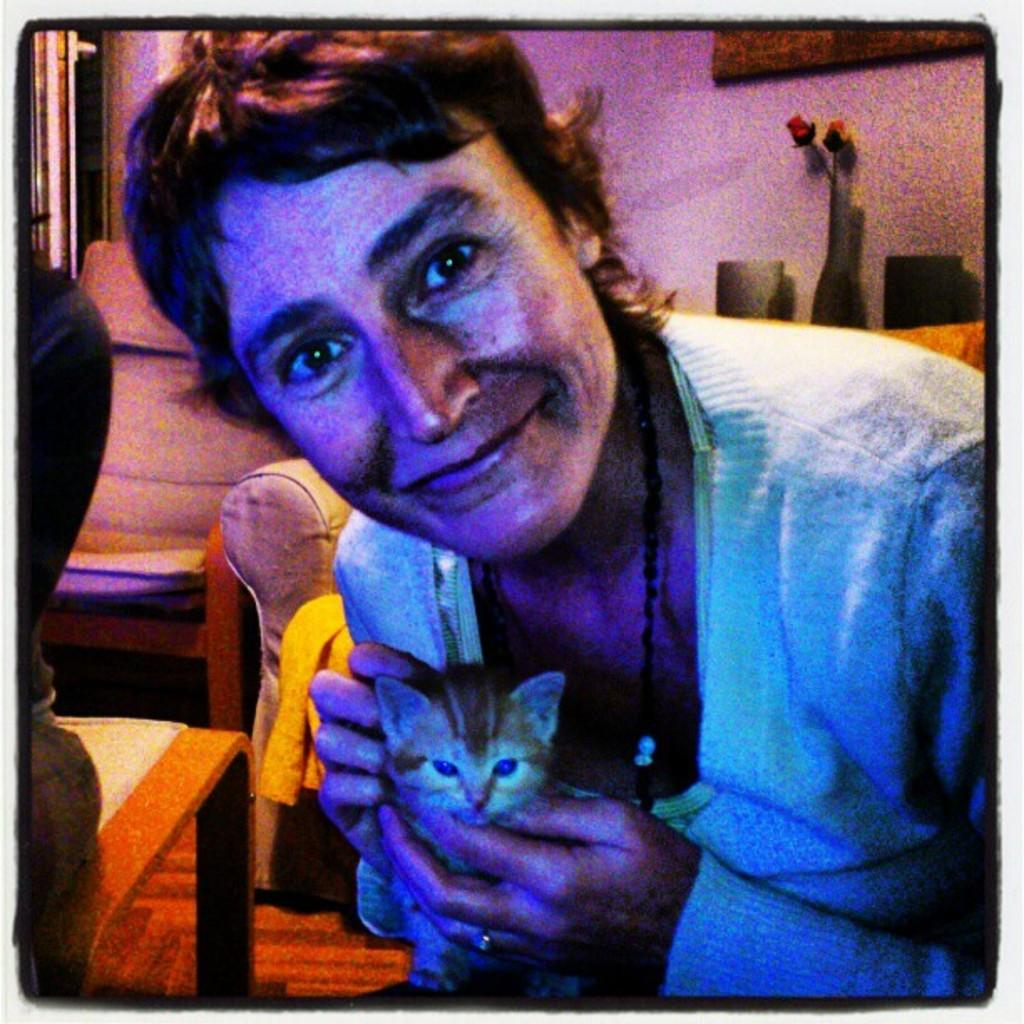What type of furniture is present in the image? There is a chair in the image. What decorative item can be seen in the image? There is a flower bouquet in the image. Can you describe the people in the image? There is a person in the image. What other living creature is present in the image? There is an animal in the image. What type of flag is being waved by the secretary in the image? There is no flag or secretary present in the image. How much water is visible in the image? There is no water present in the image. 